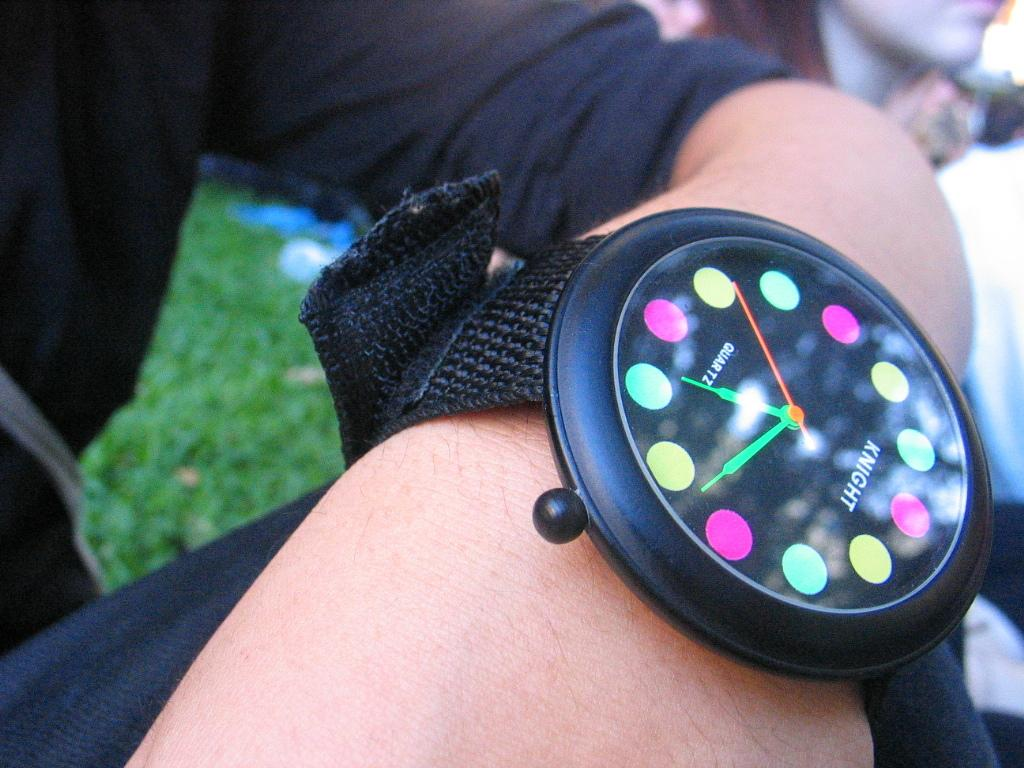<image>
Describe the image concisely. Person wearing a black watch which says KNIGHT on it. 